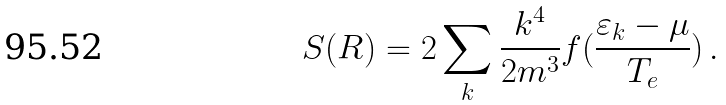<formula> <loc_0><loc_0><loc_500><loc_500>S ( { R } ) = 2 \sum _ { k } \frac { k ^ { 4 } } { 2 m ^ { 3 } } f ( \frac { \varepsilon _ { k } - \mu } { T _ { e } } ) \, .</formula> 